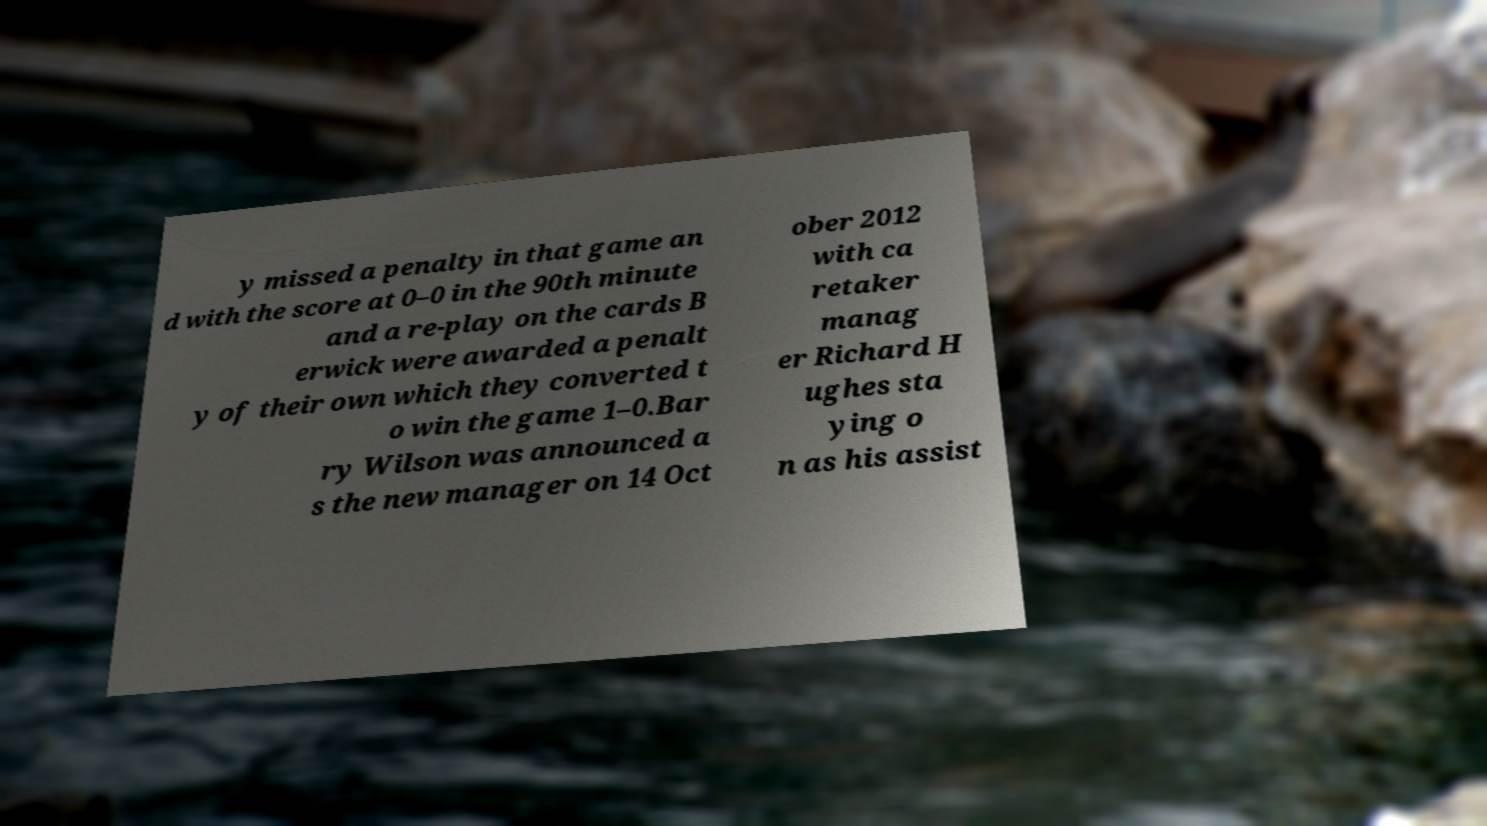Can you accurately transcribe the text from the provided image for me? y missed a penalty in that game an d with the score at 0–0 in the 90th minute and a re-play on the cards B erwick were awarded a penalt y of their own which they converted t o win the game 1–0.Bar ry Wilson was announced a s the new manager on 14 Oct ober 2012 with ca retaker manag er Richard H ughes sta ying o n as his assist 